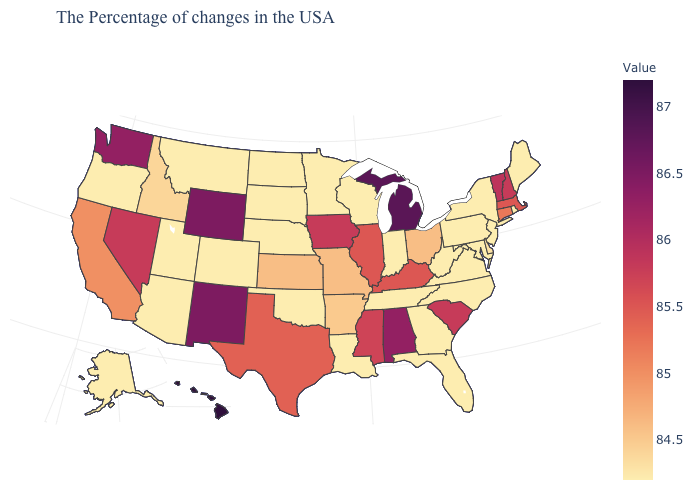Among the states that border Montana , which have the lowest value?
Quick response, please. South Dakota, North Dakota. Does Idaho have the highest value in the West?
Answer briefly. No. Which states hav the highest value in the Northeast?
Concise answer only. Vermont. Does Ohio have the lowest value in the USA?
Quick response, please. No. 